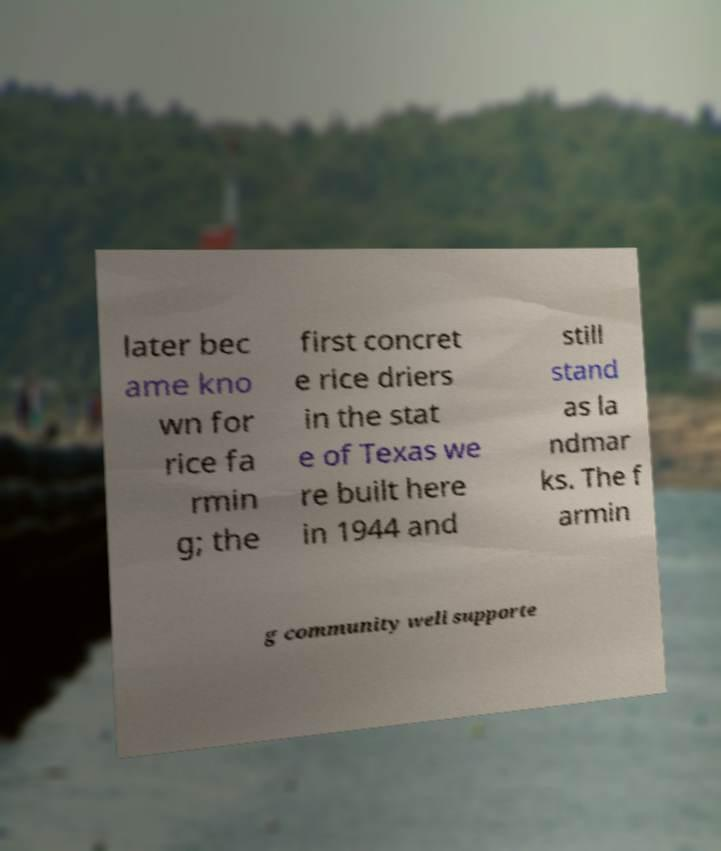Please read and relay the text visible in this image. What does it say? later bec ame kno wn for rice fa rmin g; the first concret e rice driers in the stat e of Texas we re built here in 1944 and still stand as la ndmar ks. The f armin g community well supporte 